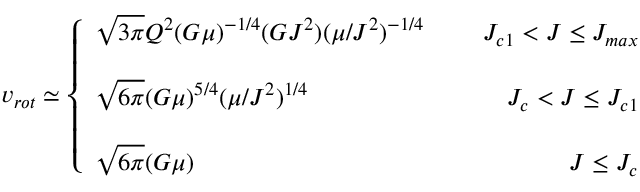<formula> <loc_0><loc_0><loc_500><loc_500>v _ { r o t } \simeq \left \{ \begin{array} { l r } { { \sqrt { 3 \pi } Q ^ { 2 } ( G \mu ) ^ { - 1 / 4 } ( G J ^ { 2 } ) ( \mu / J ^ { 2 } ) ^ { - 1 / 4 } } } & { { \, J _ { c 1 } < J \leq J _ { \max } } } \\ { { \sqrt { 6 \pi } ( G \mu ) ^ { 5 / 4 } ( \mu / J ^ { 2 } ) ^ { 1 / 4 } } } & { { \, J _ { c } < J \leq J _ { c 1 } } } \\ { { \sqrt { 6 \pi } ( G \mu ) } } & { { \, J \leq J _ { c } } } \end{array}</formula> 